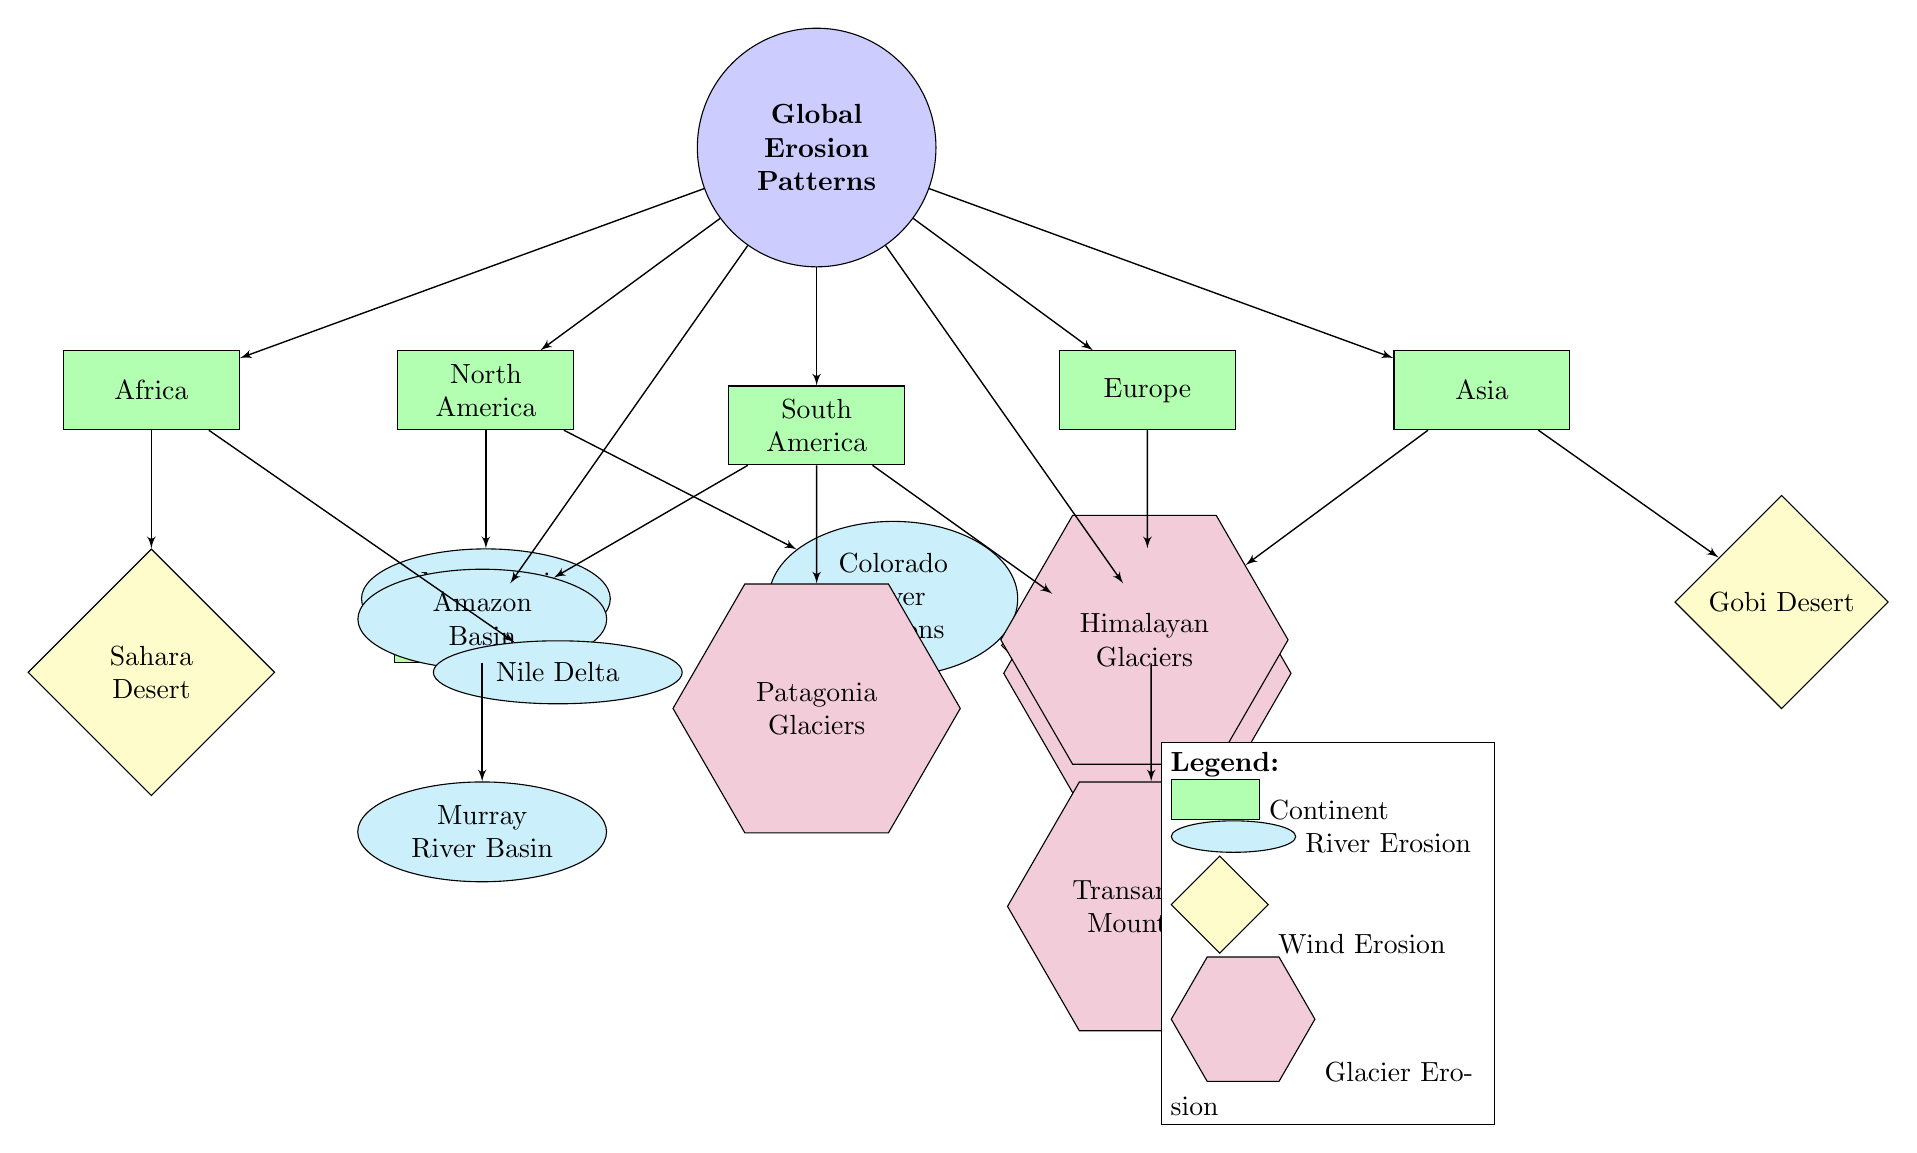What continents are represented in the diagram? The diagram includes nodes representing continents: North America, South America, Europe, Africa, Asia, Australia, and Antarctica. Counting these nodes provides the names of all continents shown.
Answer: North America, South America, Europe, Africa, Asia, Australia, Antarctica How many major river erosion sites are highlighted? The diagram indicates three specific river erosion sites connected to the continent nodes: Mississippi River Delta, Colorado River Canyons, and Nile Delta. Counting these nodes identifies the number of major river erosion sites.
Answer: 4 Which continent has the Atacama Desert as a wind erosion site? The Atacama Desert is positioned below South America in the diagram, indicating it is the wind erosion site associated with that continent.
Answer: South America What type of erosion is the Sahara Desert associated with? The Sahara Desert is shown as a wind erosion node beneath Africa in the diagram, indicating that it is marked for wind erosion.
Answer: Wind Erosion Which continent has the most major glacier erosion sites? The diagram shows glacier erosion sites for Europe (Alps Glacier Sites), Asia (Himalayan Glaciers), South America (Patagonia Glaciers), and Antarctica (Transantarctic Mountains). However, the counts are equal; hence we consider those with glacier sites.
Answer: 4 How many types of erosion are represented visually in the diagram? The diagram presents three distinct types of erosion: river, wind, and glacier. By identifying the legends and their corresponding shapes, we can count these three types visually depicted.
Answer: 4 Which glacier site is found in Antarctica? The diagram explicitly lists the Transantarctic Mountains as the glacier erosion site connected to Antarctica. Locating the node associated with Antarctica leads to this identification.
Answer: Transantarctic Mountains What is the relationship between the Mississippi River and North America? The Mississippi River Delta is a river erosion site linked directly beneath the continent node of North America, indicating a clear relationship between the two in the diagram.
Answer: Mississippi River Delta 